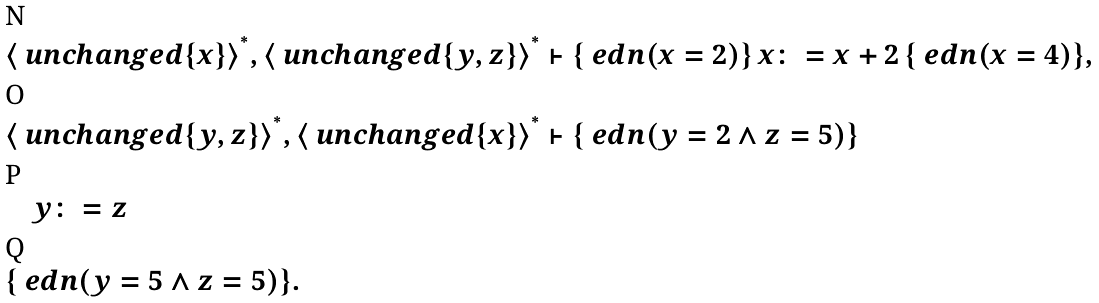Convert formula to latex. <formula><loc_0><loc_0><loc_500><loc_500>& \langle \ u n c h a n g e d \{ x \} \rangle ^ { ^ { * } } , \langle \ u n c h a n g e d \{ y , z \} \rangle ^ { ^ { * } } \vdash \{ \ e d n ( x = 2 ) \} \, x \colon = x + 2 \, \{ \ e d n ( x = 4 ) \} , \\ & \langle \ u n c h a n g e d \{ y , z \} \rangle ^ { ^ { * } } , \langle \ u n c h a n g e d \{ x \} \rangle ^ { ^ { * } } \vdash \{ \ e d n ( y = 2 \land z = 5 ) \} \\ & \quad y \colon = z \\ & \{ \ e d n ( y = 5 \land z = 5 ) \} .</formula> 